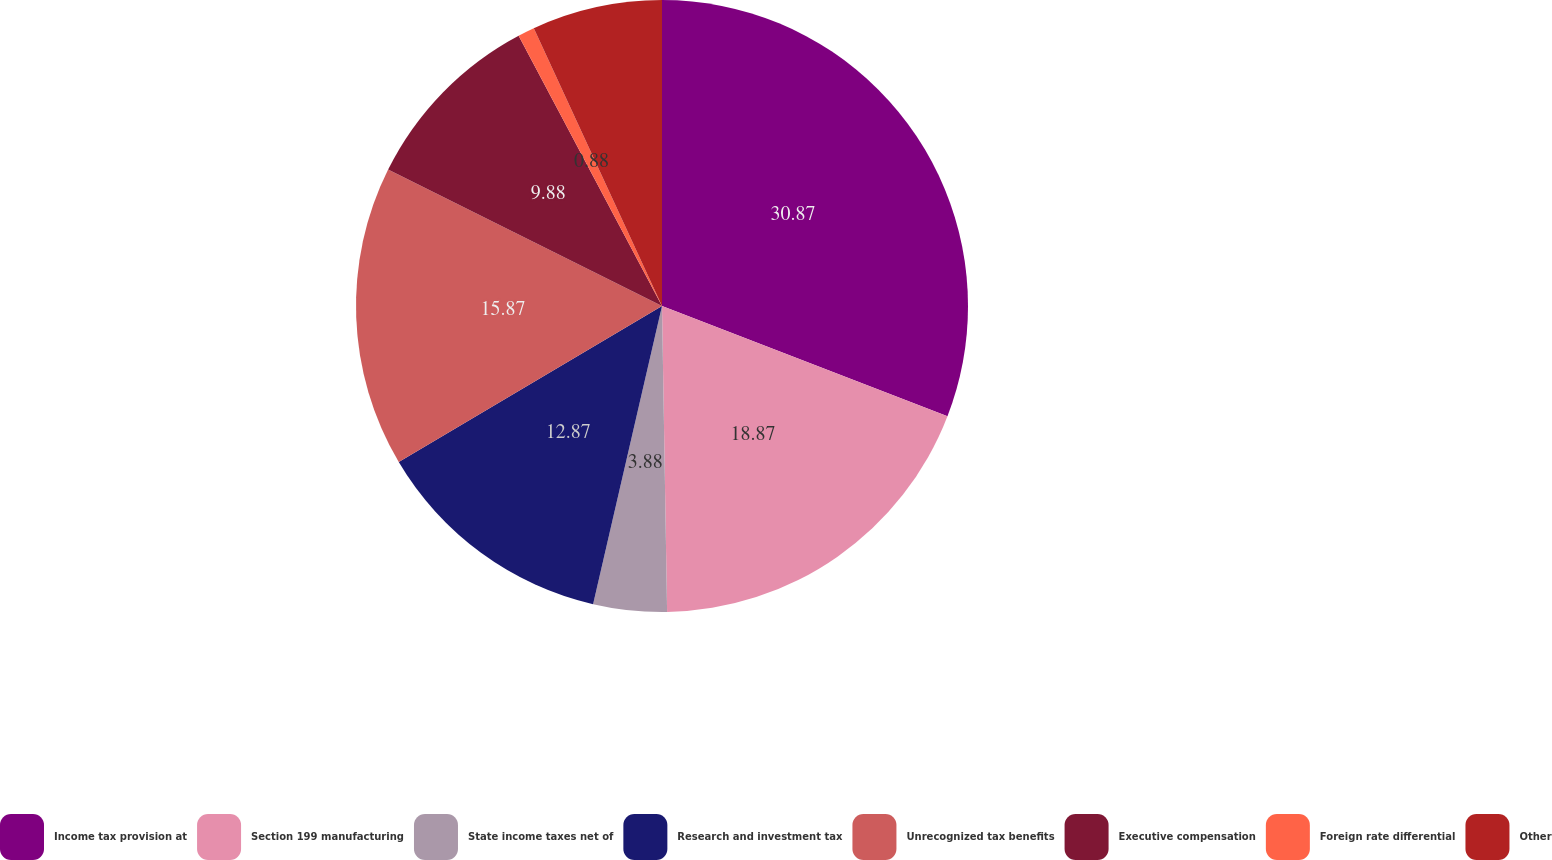<chart> <loc_0><loc_0><loc_500><loc_500><pie_chart><fcel>Income tax provision at<fcel>Section 199 manufacturing<fcel>State income taxes net of<fcel>Research and investment tax<fcel>Unrecognized tax benefits<fcel>Executive compensation<fcel>Foreign rate differential<fcel>Other<nl><fcel>30.86%<fcel>18.87%<fcel>3.88%<fcel>12.87%<fcel>15.87%<fcel>9.88%<fcel>0.88%<fcel>6.88%<nl></chart> 